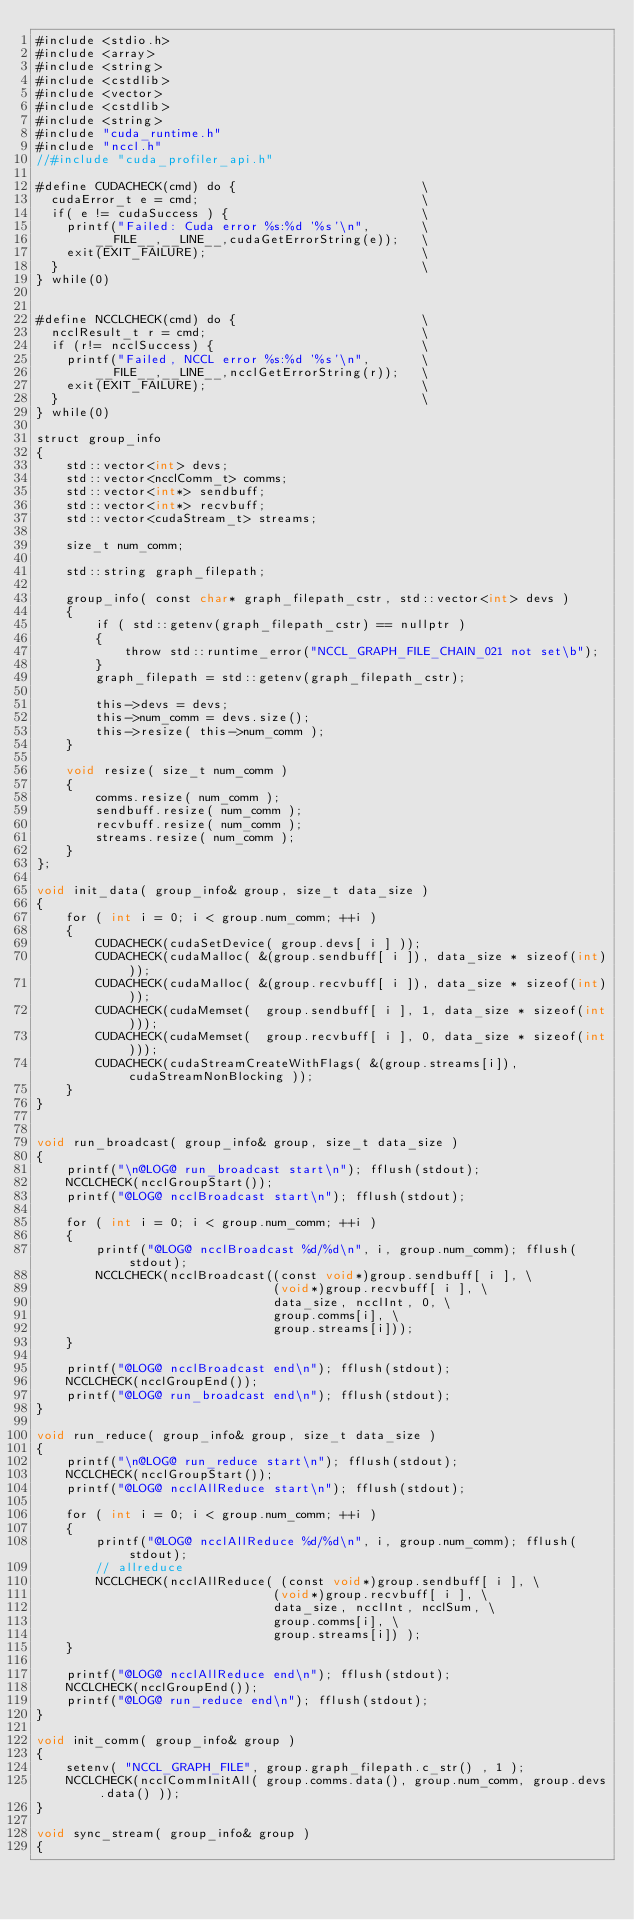Convert code to text. <code><loc_0><loc_0><loc_500><loc_500><_Cuda_>#include <stdio.h>
#include <array>
#include <string>
#include <cstdlib>
#include <vector>
#include <cstdlib>
#include <string>
#include "cuda_runtime.h"
#include "nccl.h"
//#include "cuda_profiler_api.h"

#define CUDACHECK(cmd) do {                         \
  cudaError_t e = cmd;                              \
  if( e != cudaSuccess ) {                          \
    printf("Failed: Cuda error %s:%d '%s'\n",       \
        __FILE__,__LINE__,cudaGetErrorString(e));   \
    exit(EXIT_FAILURE);                             \
  }                                                 \
} while(0)


#define NCCLCHECK(cmd) do {                         \
  ncclResult_t r = cmd;                             \
  if (r!= ncclSuccess) {                            \
    printf("Failed, NCCL error %s:%d '%s'\n",       \
        __FILE__,__LINE__,ncclGetErrorString(r));   \
    exit(EXIT_FAILURE);                             \
  }                                                 \
} while(0)

struct group_info
{
    std::vector<int> devs;
    std::vector<ncclComm_t> comms;
    std::vector<int*> sendbuff;
    std::vector<int*> recvbuff;
    std::vector<cudaStream_t> streams;

    size_t num_comm;

    std::string graph_filepath;

    group_info( const char* graph_filepath_cstr, std::vector<int> devs )
    {
        if ( std::getenv(graph_filepath_cstr) == nullptr )
        {
            throw std::runtime_error("NCCL_GRAPH_FILE_CHAIN_021 not set\b");
        }
        graph_filepath = std::getenv(graph_filepath_cstr);

        this->devs = devs;
        this->num_comm = devs.size();
        this->resize( this->num_comm );
    }

    void resize( size_t num_comm )
    {
        comms.resize( num_comm );
        sendbuff.resize( num_comm );
        recvbuff.resize( num_comm );
        streams.resize( num_comm );
    }
};

void init_data( group_info& group, size_t data_size )
{
    for ( int i = 0; i < group.num_comm; ++i )
    {
        CUDACHECK(cudaSetDevice( group.devs[ i ] ));
        CUDACHECK(cudaMalloc( &(group.sendbuff[ i ]), data_size * sizeof(int)));
        CUDACHECK(cudaMalloc( &(group.recvbuff[ i ]), data_size * sizeof(int)));
        CUDACHECK(cudaMemset(  group.sendbuff[ i ], 1, data_size * sizeof(int)));
        CUDACHECK(cudaMemset(  group.recvbuff[ i ], 0, data_size * sizeof(int)));
        CUDACHECK(cudaStreamCreateWithFlags( &(group.streams[i]), cudaStreamNonBlocking ));
    }
}


void run_broadcast( group_info& group, size_t data_size )
{
    printf("\n@LOG@ run_broadcast start\n"); fflush(stdout);
    NCCLCHECK(ncclGroupStart());
    printf("@LOG@ ncclBroadcast start\n"); fflush(stdout);

    for ( int i = 0; i < group.num_comm; ++i ) 
    {
        printf("@LOG@ ncclBroadcast %d/%d\n", i, group.num_comm); fflush(stdout);
        NCCLCHECK(ncclBroadcast((const void*)group.sendbuff[ i ], \
                                (void*)group.recvbuff[ i ], \
                                data_size, ncclInt, 0, \
                                group.comms[i], \
                                group.streams[i]));
    }

    printf("@LOG@ ncclBroadcast end\n"); fflush(stdout);
    NCCLCHECK(ncclGroupEnd());
    printf("@LOG@ run_broadcast end\n"); fflush(stdout);
}

void run_reduce( group_info& group, size_t data_size )
{
    printf("\n@LOG@ run_reduce start\n"); fflush(stdout);
    NCCLCHECK(ncclGroupStart());
    printf("@LOG@ ncclAllReduce start\n"); fflush(stdout);

    for ( int i = 0; i < group.num_comm; ++i ) 
    {
        printf("@LOG@ ncclAllReduce %d/%d\n", i, group.num_comm); fflush(stdout);
        // allreduce
        NCCLCHECK(ncclAllReduce( (const void*)group.sendbuff[ i ], \
                                (void*)group.recvbuff[ i ], \
                                data_size, ncclInt, ncclSum, \
                                group.comms[i], \
                                group.streams[i]) );
    }

    printf("@LOG@ ncclAllReduce end\n"); fflush(stdout);
    NCCLCHECK(ncclGroupEnd());
    printf("@LOG@ run_reduce end\n"); fflush(stdout);
}

void init_comm( group_info& group )
{
    setenv( "NCCL_GRAPH_FILE", group.graph_filepath.c_str() , 1 );
    NCCLCHECK(ncclCommInitAll( group.comms.data(), group.num_comm, group.devs.data() ));
}

void sync_stream( group_info& group )
{</code> 